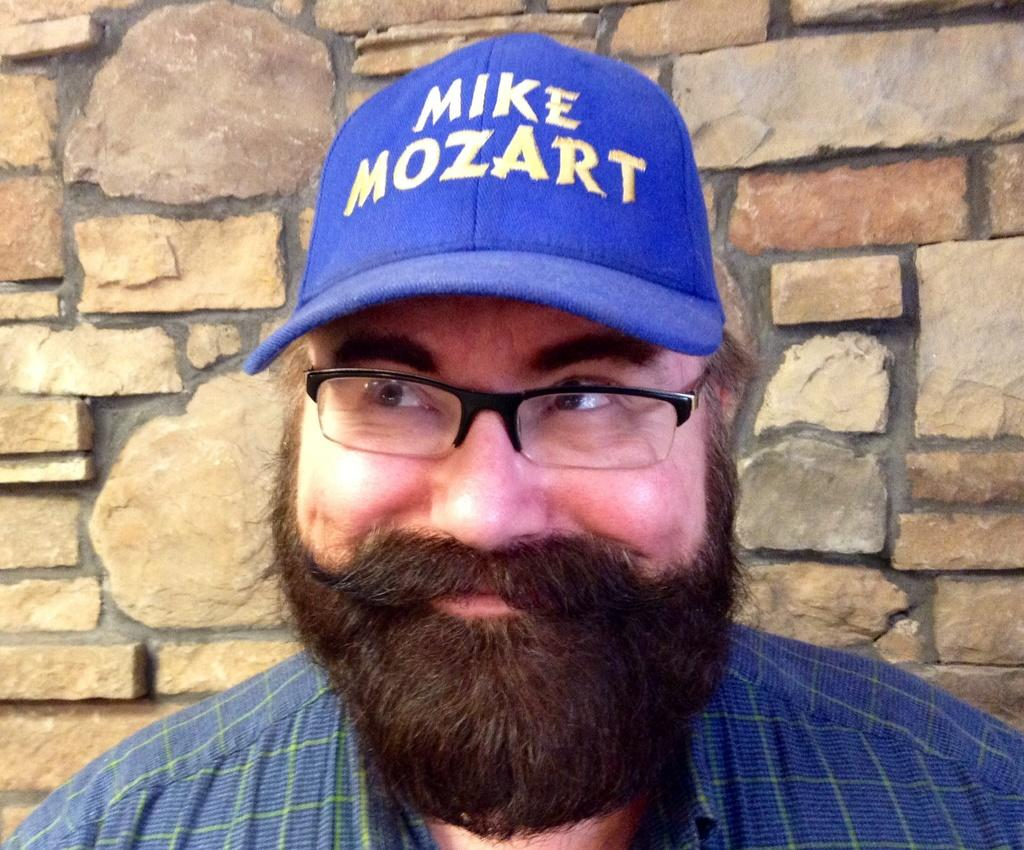Who is present in the image? There is a man in the picture. What is the man wearing on his head? The man is wearing a cap. What type of eyewear is the man wearing? The man is wearing spectacles. What type of clothing is the man wearing on his upper body? The man is wearing a shirt. What is the man's facial expression in the image? The man is smiling. Where is the man located in the image? The man is standing near a wall. What type of wax can be seen melting near the man in the image? There is no wax present in the image. What type of eggnog is the man holding in the image? There is no eggnog present in the image. 